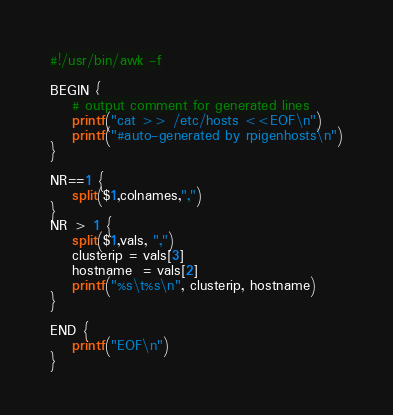<code> <loc_0><loc_0><loc_500><loc_500><_Awk_>#!/usr/bin/awk -f

BEGIN {
	# output comment for generated lines
	printf("cat >> /etc/hosts <<EOF\n")
	printf("#auto-generated by rpigenhosts\n")
}

NR==1 {
	split($1,colnames,",")
}
NR > 1 {
	split($1,vals, ",")
	clusterip = vals[3]
	hostname  = vals[2]
	printf("%s\t%s\n", clusterip, hostname)
}

END {
	printf("EOF\n")
}
</code> 